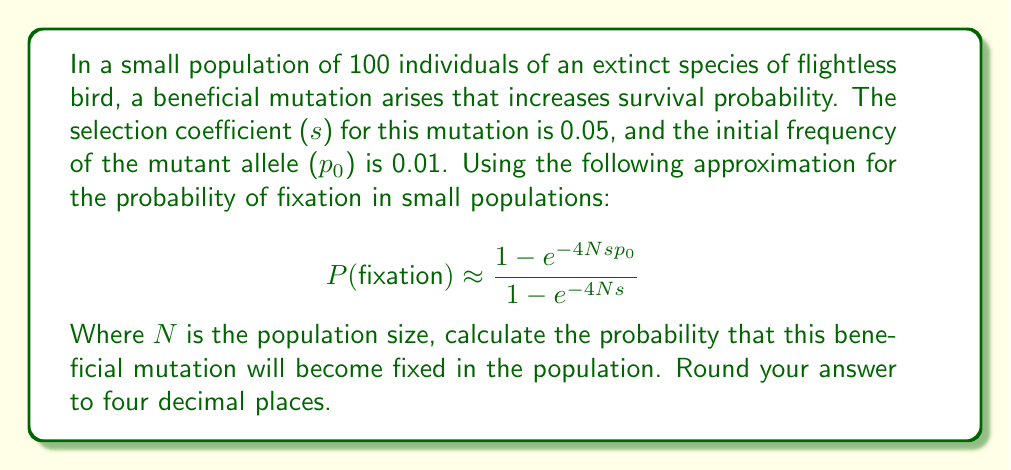Show me your answer to this math problem. To solve this problem, we'll follow these steps:

1. Identify the given values:
   N = 100 (population size)
   s = 0.05 (selection coefficient)
   p₀ = 0.01 (initial frequency of the mutant allele)

2. Substitute these values into the fixation probability formula:

   $$P(fixation) \approx \frac{1 - e^{-4Nsp_0}}{1 - e^{-4Ns}}$$

3. Calculate the exponents:
   -4Nsp₀ = -4 * 100 * 0.05 * 0.01 = -0.2
   -4Ns = -4 * 100 * 0.05 = -20

4. Compute e raised to these powers:
   $e^{-0.2} \approx 0.8187$
   $e^{-20} \approx 2.0612 \times 10^{-9}$

5. Substitute these values into the formula:

   $$P(fixation) \approx \frac{1 - 0.8187}{1 - 2.0612 \times 10^{-9}}$$

6. Compute the numerator and denominator:
   Numerator: 1 - 0.8187 = 0.1813
   Denominator: 1 - $2.0612 \times 10^{-9}$ ≈ 0.9999999979

7. Divide the numerator by the denominator:
   0.1813 / 0.9999999979 ≈ 0.1813

8. Round to four decimal places: 0.1813

This result suggests that there is approximately an 18.13% chance that the beneficial mutation will become fixed in this small population of extinct flightless birds.
Answer: 0.1813 